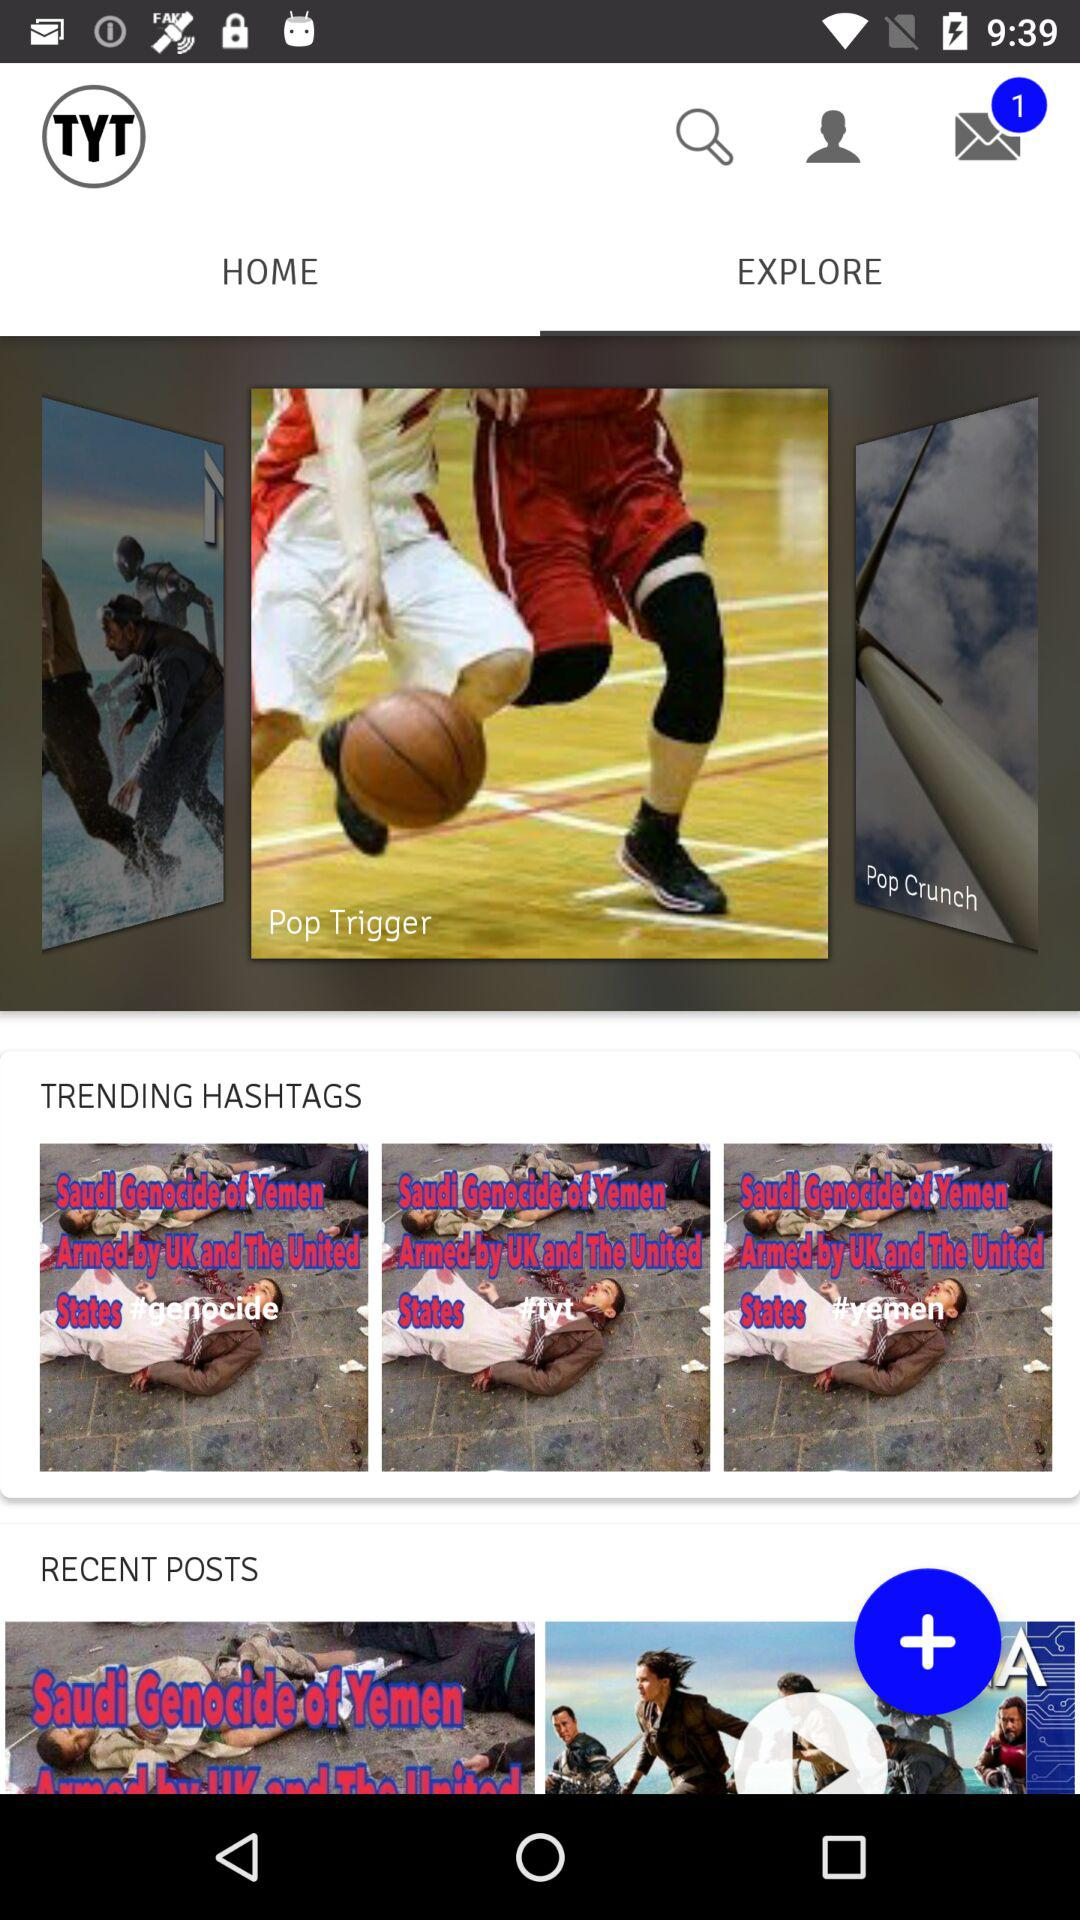How many emails are unread? There is 1 unread email. 